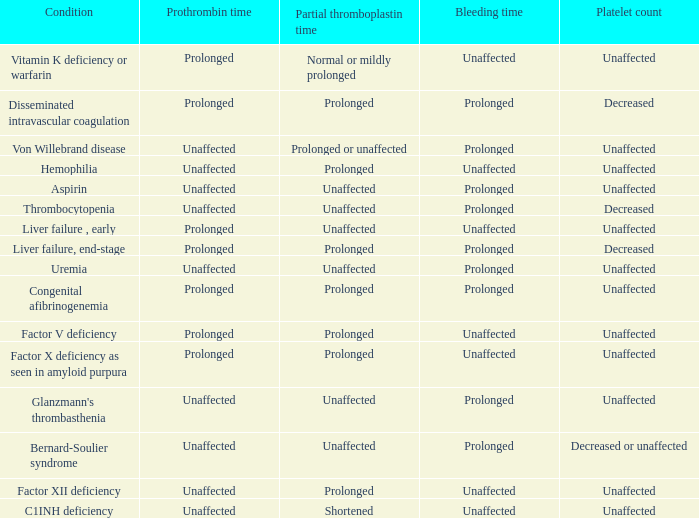Which partial thromboplastin time signifies early liver dysfunction condition? Unaffected. 